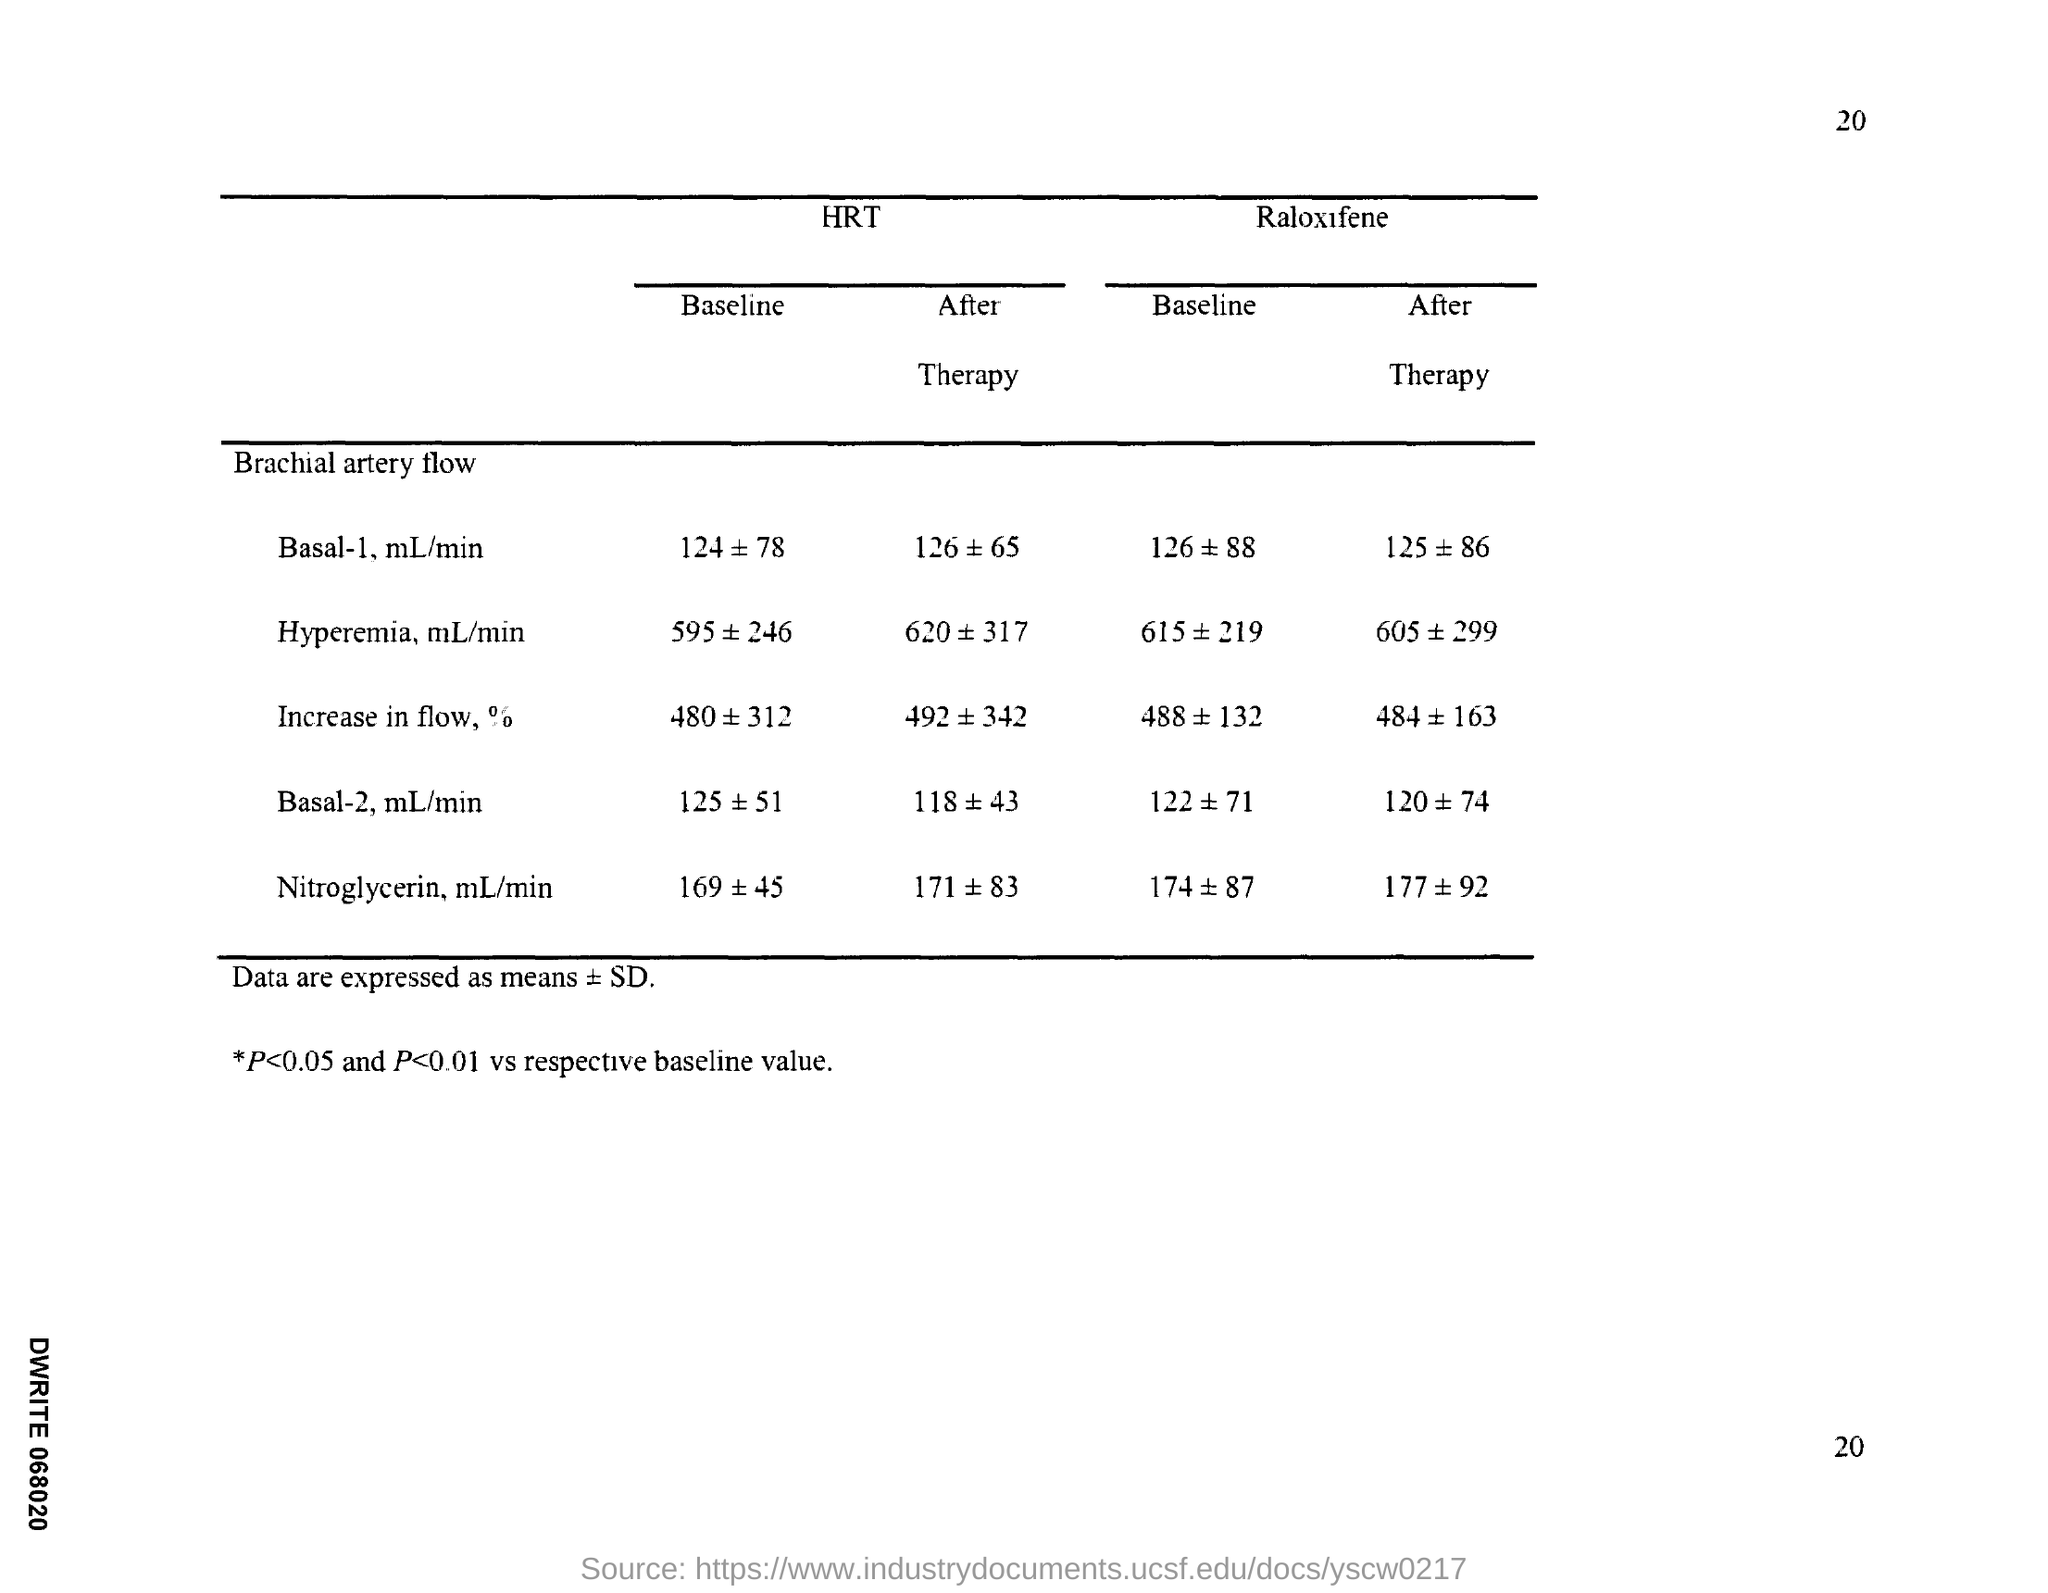Indicate a few pertinent items in this graphic. The page number is 20. 